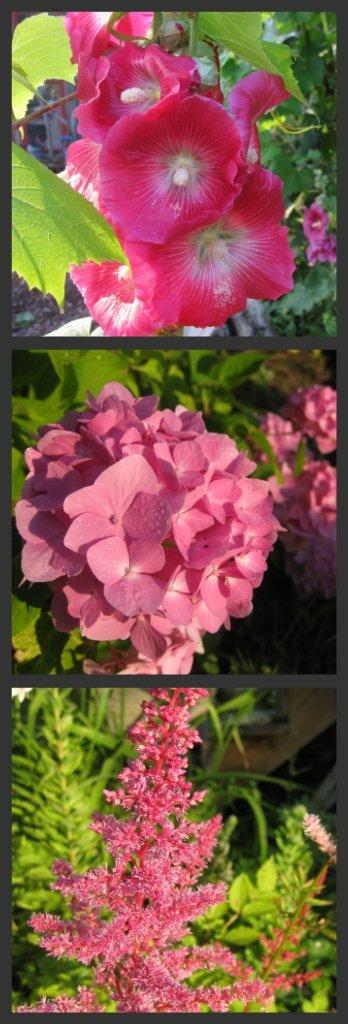What is the main subject of the image? The image contains a collage of pictures. What types of natural elements are included in the collage? The collage includes a group of flowers, leaves, and plants. Can you see the chin of the fairies in the collage? There are no fairies present in the collage, so it is not possible to see their chins. 